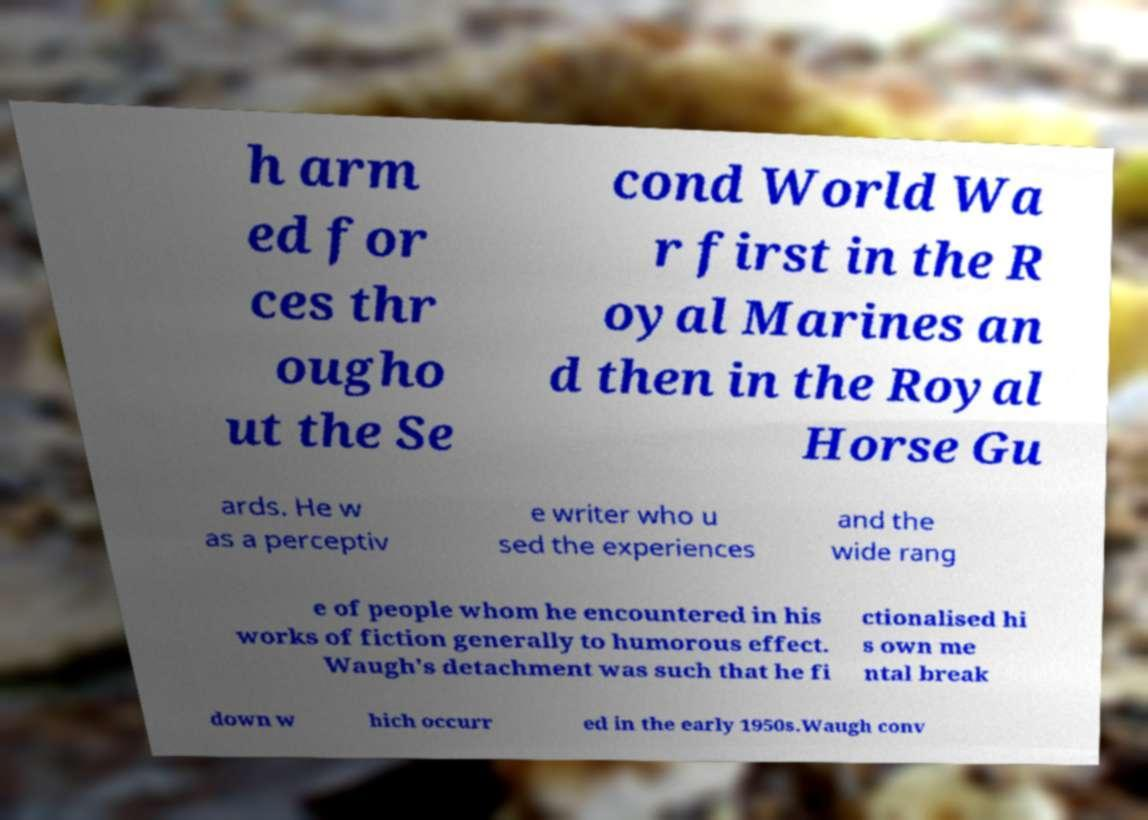I need the written content from this picture converted into text. Can you do that? h arm ed for ces thr ougho ut the Se cond World Wa r first in the R oyal Marines an d then in the Royal Horse Gu ards. He w as a perceptiv e writer who u sed the experiences and the wide rang e of people whom he encountered in his works of fiction generally to humorous effect. Waugh's detachment was such that he fi ctionalised hi s own me ntal break down w hich occurr ed in the early 1950s.Waugh conv 